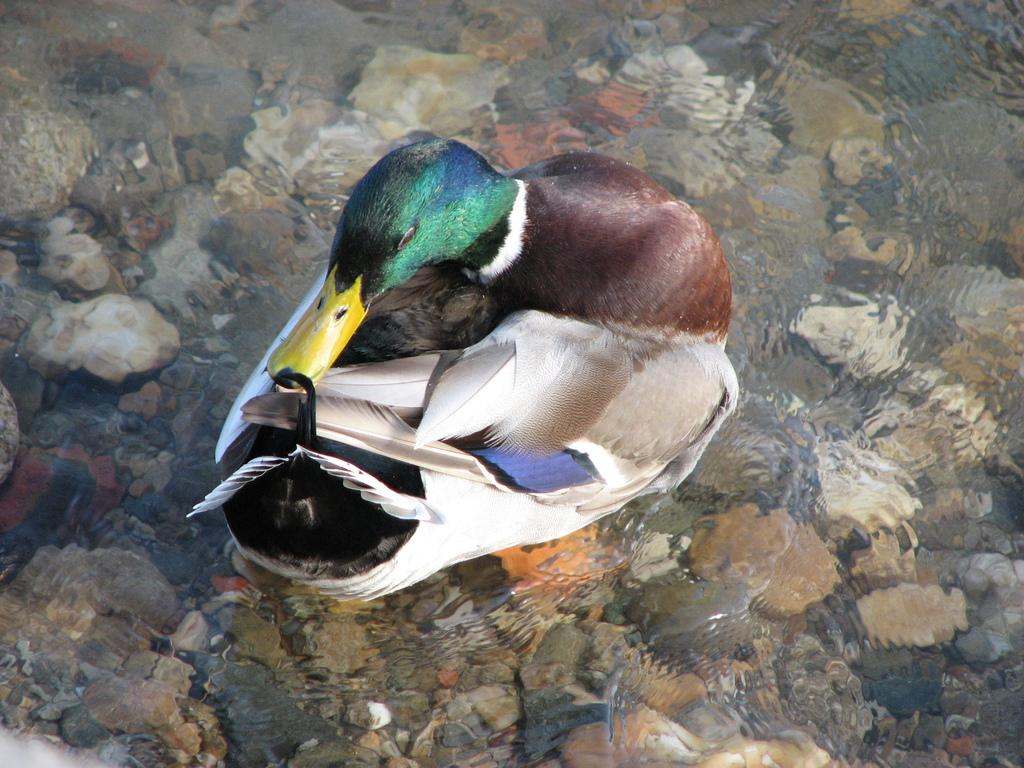What animal can be seen in the water in the image? There is a duck swimming in the water in the image. What else can be found in the water besides the duck? There are stones and pebbles in the water. How many planes can be seen flying over the duck in the image? There are no planes visible in the image; it only features a duck swimming in the water and stones and pebbles in the water. 